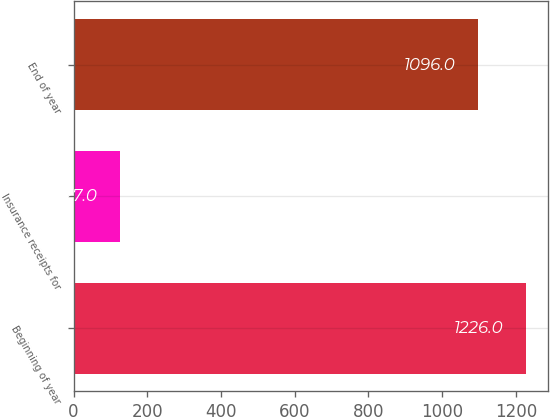Convert chart to OTSL. <chart><loc_0><loc_0><loc_500><loc_500><bar_chart><fcel>Beginning of year<fcel>Insurance receipts for<fcel>End of year<nl><fcel>1226<fcel>127<fcel>1096<nl></chart> 